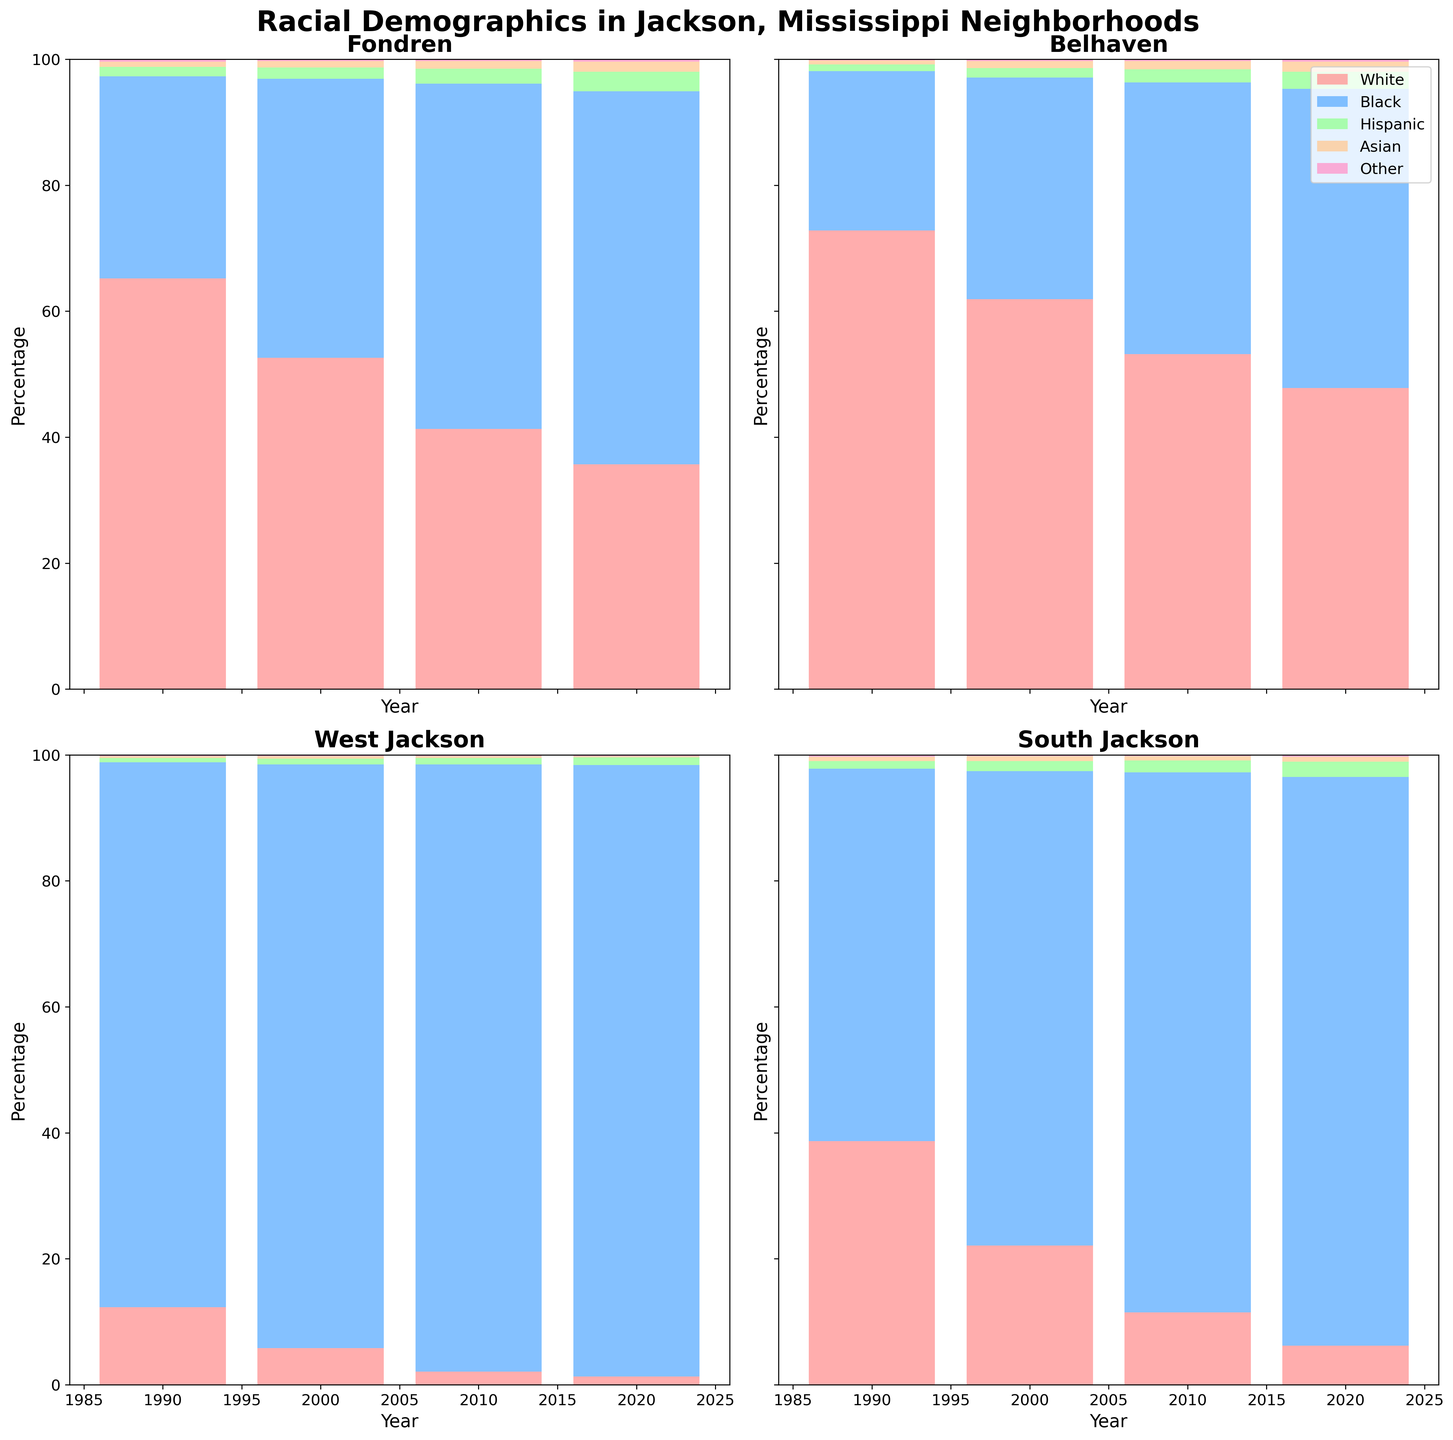What's the title of the figure? The title is usually placed at the top of the figure. Here, it prominently states "Racial Demographics in Jackson, Mississippi Neighborhoods."
Answer: Racial Demographics in Jackson, Mississippi Neighborhoods Which neighborhood had the highest percentage of Black residents in 2020? Look at the top of the bars in the year 2020 for each subplot and identify which one has the highest value for Black residents.
Answer: West Jackson How did the percentage of Hispanic residents change in Fondren from 1990 to 2020? Trace the Hispanic percentage in Fondren from the 1990 bar to the 2020 bar and observe the change.
Answer: Increased from 1.5 to 3.1 Compare the percentage of White residents in Belhaven between 1990 and 2020. Check the 1990 and 2020 bars for the White demographic in the Belhaven subplot, look at the top values.
Answer: Decreased from 72.8 to 47.8 Which neighborhood had the most dramatic change in the percentage of White residents over the span of 30 years? By going through the plots and comparing the percentages for 1990 and 2020, identify which neighborhood had the largest decrease.
Answer: South Jackson What is the percentage difference of Black residents between South Jackson and Belhaven in 2010? Find the percentages for Black residents in South Jackson and Belhaven in 2010 and then compute the difference.
Answer: 42.6 (85.7 - 43.1) Which race had the least percentage representation across all neighborhoods and all years? Inspect each subplot to see which race consistently has the lowest percentage across all years.
Answer: Asian In which year did South Jackson see the largest increase in the percentage of Black residents? Compare the heights of the Black bars in the South Jackson subplot year over year to see the largest positive change.
Answer: Between 1990 and 2000 How does the racial makeup of West Jackson in 1990 compare to West Jackson in 2020? Compare 1990 and 2020 bars for each demographic in the West Jackson subplot to identify the trends and changes.
Answer: More Black residents, fewer White residents In 2000, which neighborhood had the closest percentage distribution between White and Black residents? Look at the 2000 bars for both White and Black populations across all subplots and find the neighborhood where the percentages are most similar.
Answer: Fondren 